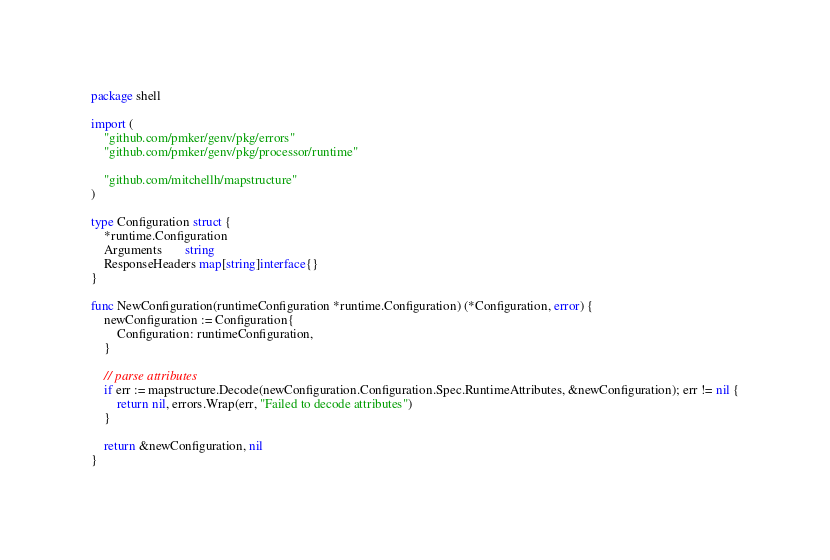<code> <loc_0><loc_0><loc_500><loc_500><_Go_>package shell

import (
	"github.com/pmker/genv/pkg/errors"
	"github.com/pmker/genv/pkg/processor/runtime"

	"github.com/mitchellh/mapstructure"
)

type Configuration struct {
	*runtime.Configuration
	Arguments       string
	ResponseHeaders map[string]interface{}
}

func NewConfiguration(runtimeConfiguration *runtime.Configuration) (*Configuration, error) {
	newConfiguration := Configuration{
		Configuration: runtimeConfiguration,
	}

	// parse attributes
	if err := mapstructure.Decode(newConfiguration.Configuration.Spec.RuntimeAttributes, &newConfiguration); err != nil {
		return nil, errors.Wrap(err, "Failed to decode attributes")
	}

	return &newConfiguration, nil
}
</code> 